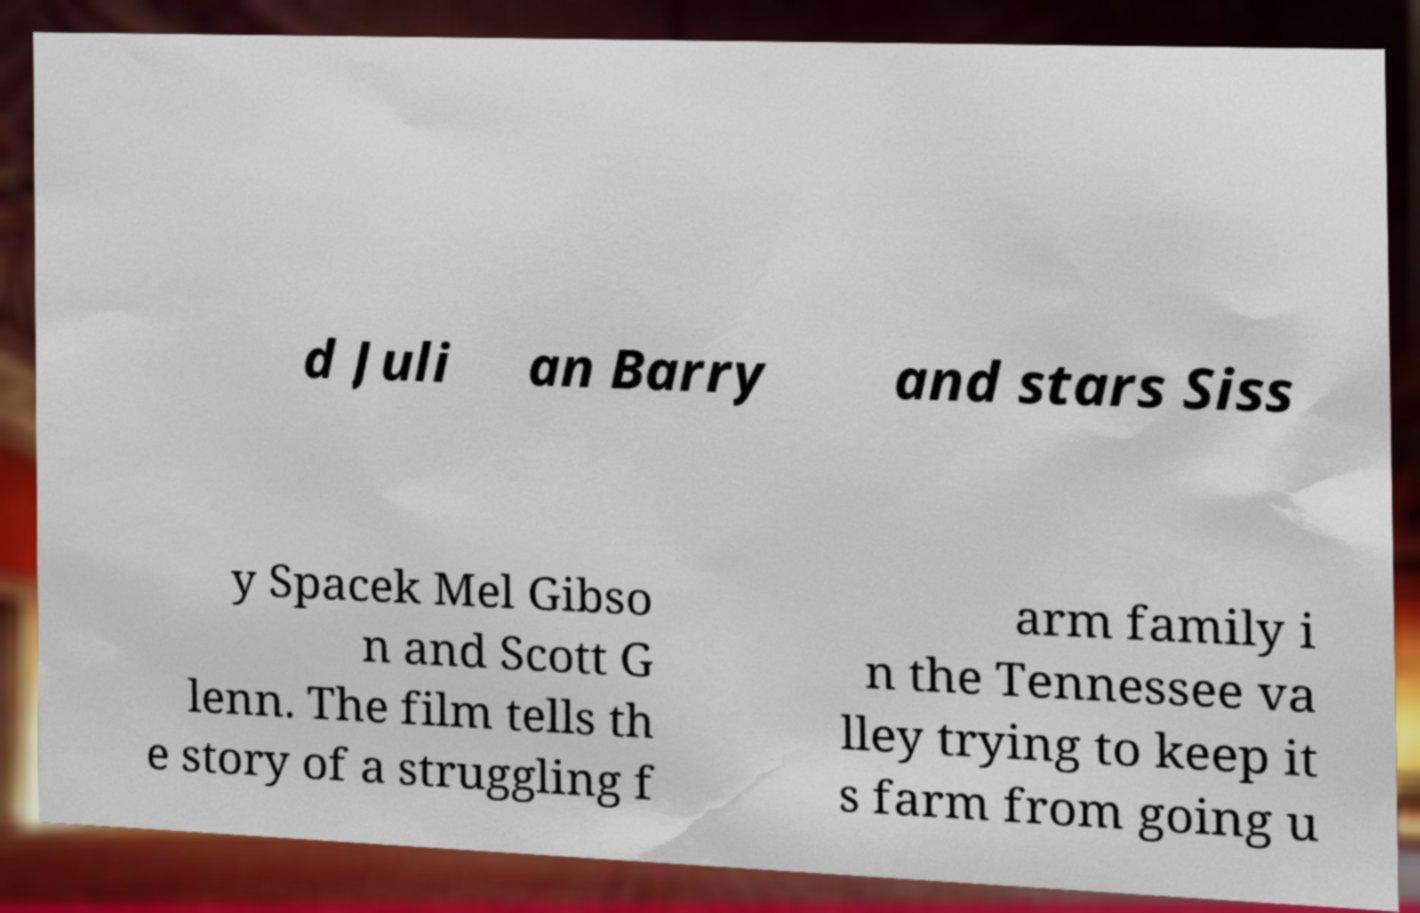Please identify and transcribe the text found in this image. d Juli an Barry and stars Siss y Spacek Mel Gibso n and Scott G lenn. The film tells th e story of a struggling f arm family i n the Tennessee va lley trying to keep it s farm from going u 